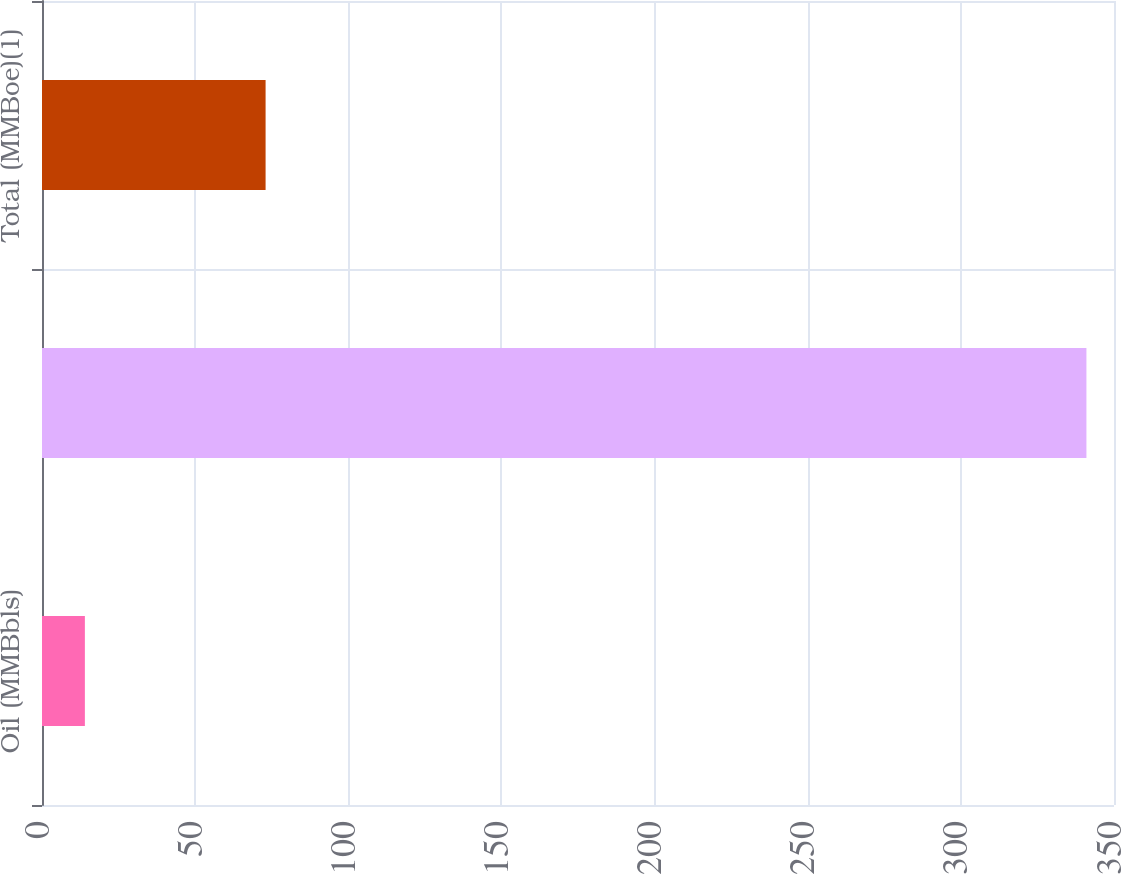Convert chart to OTSL. <chart><loc_0><loc_0><loc_500><loc_500><bar_chart><fcel>Oil (MMBbls)<fcel>Natural gas (Bcf)<fcel>Total (MMBoe)(1)<nl><fcel>14<fcel>341<fcel>73<nl></chart> 